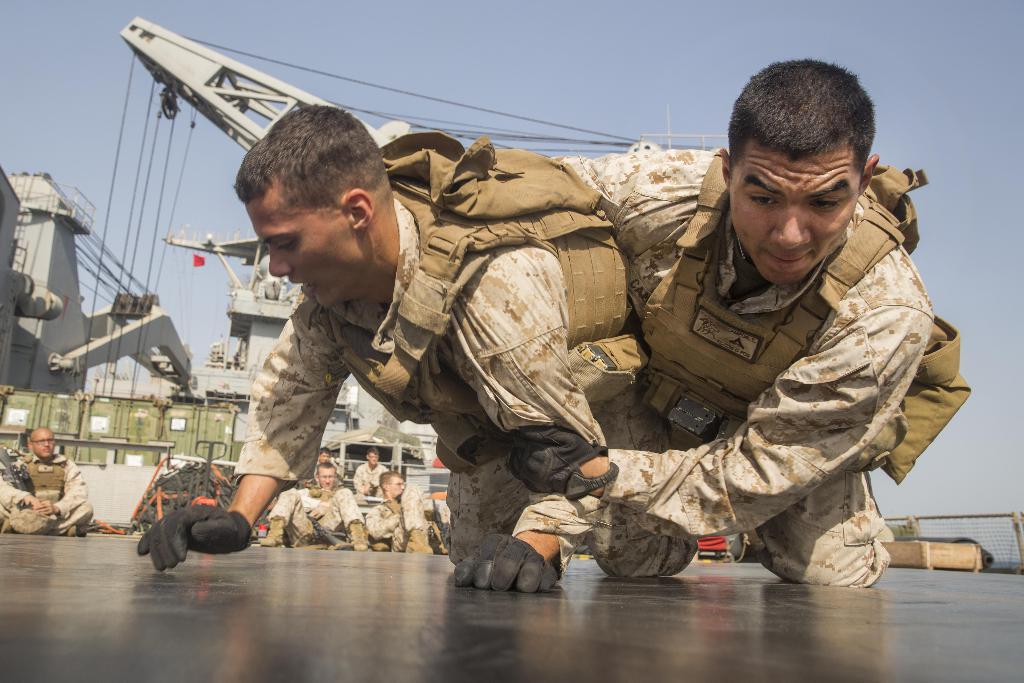What is happening in the center of the image? There are people fighting in the center of the image. What are the people in the background of the image doing? There are people sitting in the background of the image. What else can be seen in the image besides the people? There are machines visible in the image. What is the price of the son in the image? There is no son present in the image, and therefore no price can be determined. 